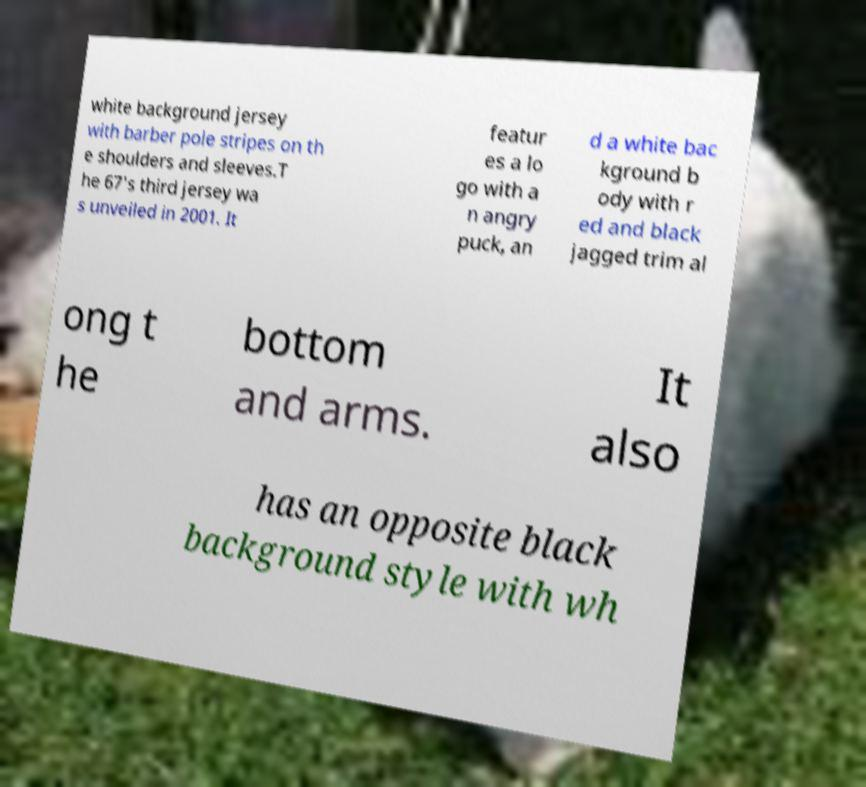Please read and relay the text visible in this image. What does it say? white background jersey with barber pole stripes on th e shoulders and sleeves.T he 67's third jersey wa s unveiled in 2001. It featur es a lo go with a n angry puck, an d a white bac kground b ody with r ed and black jagged trim al ong t he bottom and arms. It also has an opposite black background style with wh 